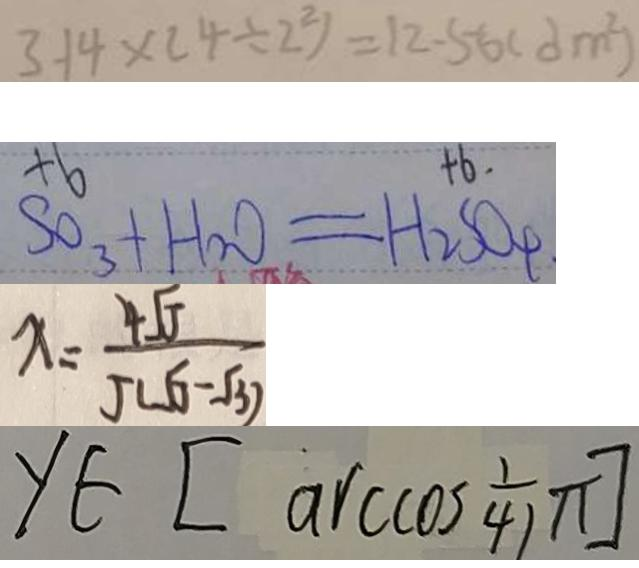<formula> <loc_0><loc_0><loc_500><loc_500>3 . 1 4 \times ( 4 \div 2 ^ { 2 } ) = 1 2 . 5 6 ( d m ^ { 2 } ) 
 S O _ { 3 } + H _ { 2 } O = H _ { 2 } S O _ { 4 } 
 x = \frac { 4 J } { J ( J - 3 ) } 
 y \in [ \arccos \frac { 1 } { 4 } ]</formula> 